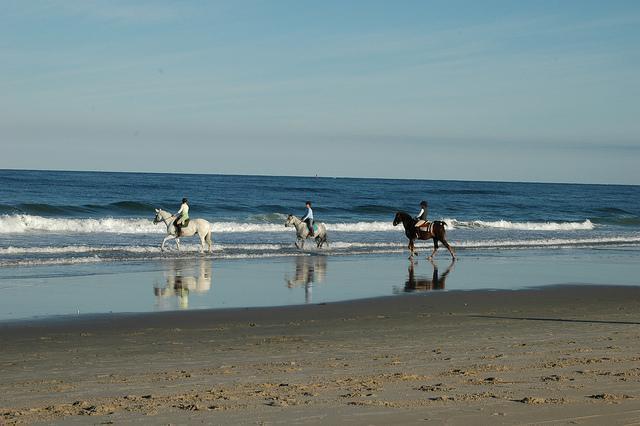How many horses are on the beach?
Give a very brief answer. 3. How many waves are coming in?
Give a very brief answer. 2. 